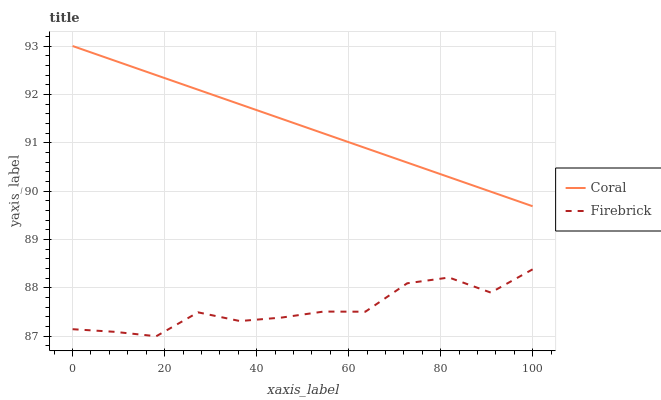Does Firebrick have the maximum area under the curve?
Answer yes or no. No. Is Firebrick the smoothest?
Answer yes or no. No. Does Firebrick have the highest value?
Answer yes or no. No. Is Firebrick less than Coral?
Answer yes or no. Yes. Is Coral greater than Firebrick?
Answer yes or no. Yes. Does Firebrick intersect Coral?
Answer yes or no. No. 